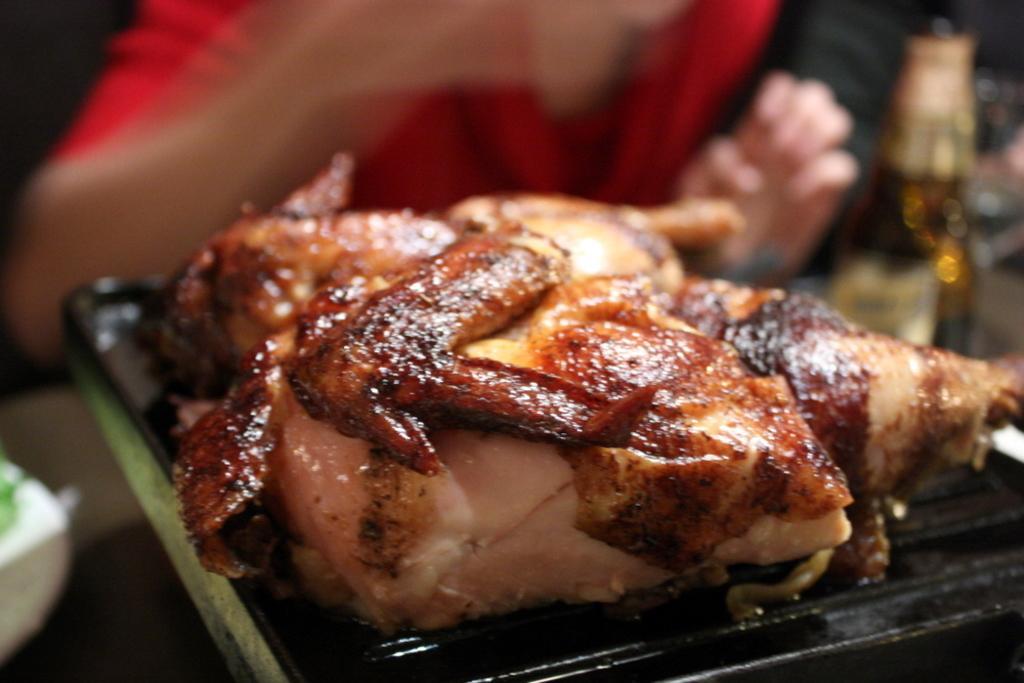How would you summarize this image in a sentence or two? In this picture there is a chicken in the center of the image on a grill and there is a bottle and a man at the top side of the image. 